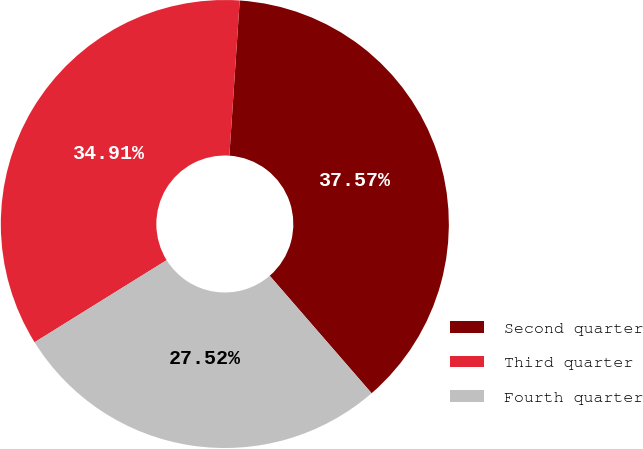Convert chart to OTSL. <chart><loc_0><loc_0><loc_500><loc_500><pie_chart><fcel>Second quarter<fcel>Third quarter<fcel>Fourth quarter<nl><fcel>37.57%<fcel>34.91%<fcel>27.52%<nl></chart> 